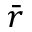Convert formula to latex. <formula><loc_0><loc_0><loc_500><loc_500>\bar { r }</formula> 